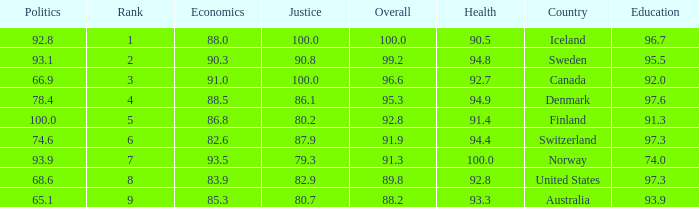What's the rank for iceland 1.0. 